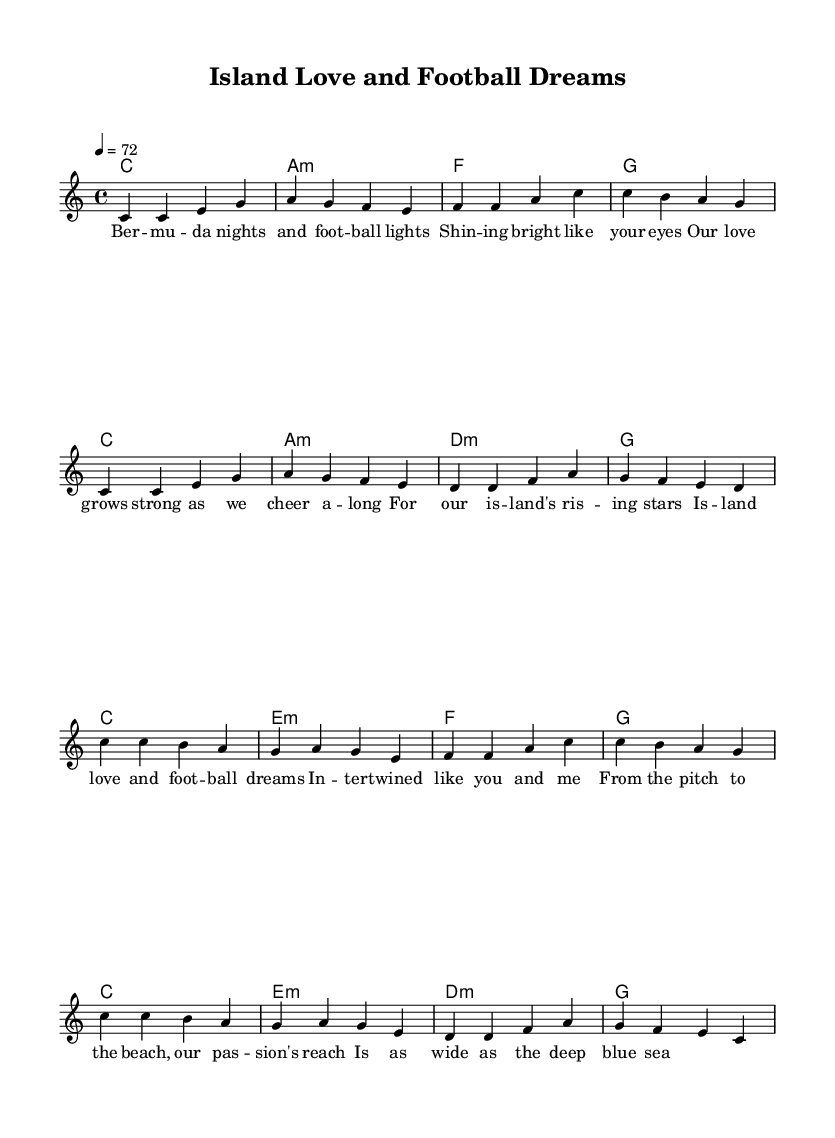What is the key signature of this music? The key signature is indicated at the beginning of the score. It is C major, which has no sharps or flats.
Answer: C major What is the time signature of this sheet music? The time signature is shown next to the key signature and is indicated as 4/4, meaning there are four beats per measure and the quarter note gets one beat.
Answer: 4/4 What is the tempo marking for this piece? The tempo marking is indicated at the top of the score after the time signature. It states "4 = 72," meaning there are 72 beats per minute, with the quarter note being the beat unit.
Answer: 72 How many measures are in the verse section? The verse section can be counted by identifying the segments separated by the vertical lines on the staff. There are 8 measures present in the verse.
Answer: 8 What are the lyrics for the chorus starting with the first word? The lyrics for the chorus start immediately after the verse and begin with "Island." This can be found by looking for the lyrics aligned with the melody in the score.
Answer: Island What is the relationship between love and sports as expressed in the lyrics? The lyrics show a strong connection between love and sports by intertwining them using phrases such as "island love and football dreams," emphasizing their deep emotional overlap.
Answer: Intertwined What instrument is indicated in this sheet music? The score indicates a staff with a treble clef, commonly used for instruments like the piano or vocals. However, there is no specific instrument mentioned, leaving it open to interpretation.
Answer: Not specified 